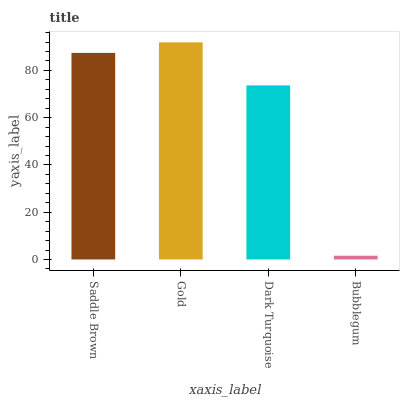Is Bubblegum the minimum?
Answer yes or no. Yes. Is Gold the maximum?
Answer yes or no. Yes. Is Dark Turquoise the minimum?
Answer yes or no. No. Is Dark Turquoise the maximum?
Answer yes or no. No. Is Gold greater than Dark Turquoise?
Answer yes or no. Yes. Is Dark Turquoise less than Gold?
Answer yes or no. Yes. Is Dark Turquoise greater than Gold?
Answer yes or no. No. Is Gold less than Dark Turquoise?
Answer yes or no. No. Is Saddle Brown the high median?
Answer yes or no. Yes. Is Dark Turquoise the low median?
Answer yes or no. Yes. Is Bubblegum the high median?
Answer yes or no. No. Is Saddle Brown the low median?
Answer yes or no. No. 